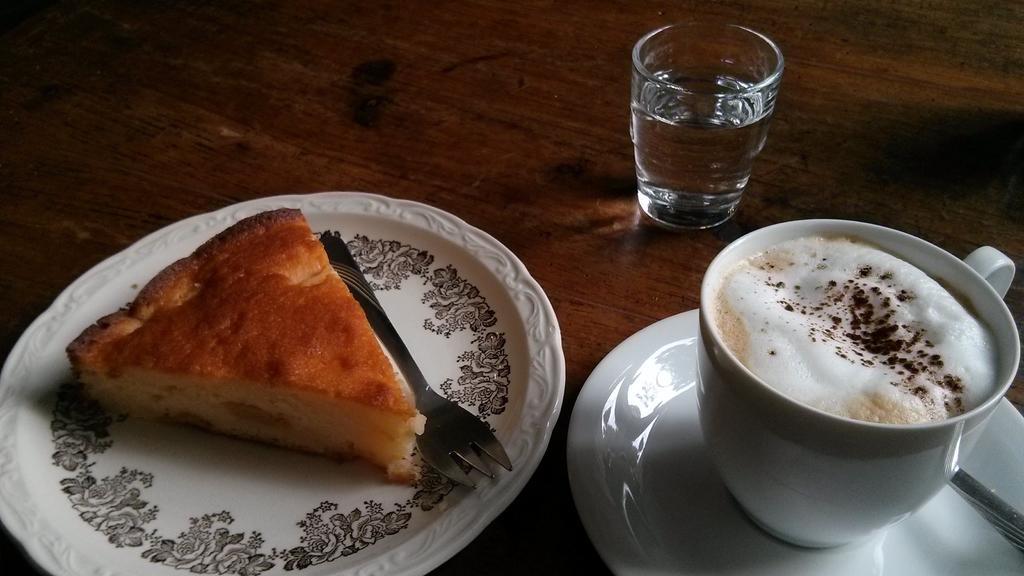What type of food is in the plate in the image? There is bread in a plate in the image. What type of beverage is in the cup in the image? There is coffee in a cup in the image. What utensils are visible in the image? There are spoons visible in the image. What type of container is present in the image? There is a glass tumbler in the image. Where are all these items placed in the image? All of these items are placed on a table. What type of fight is taking place in the image? There is no fight present in the image; it features a plate of bread, a cup of coffee, spoons, a glass tumbler, and a table. What type of wax is used to create the texture of the bread in the image? There is no wax present in the image; it is a photograph or digital representation of real bread. 